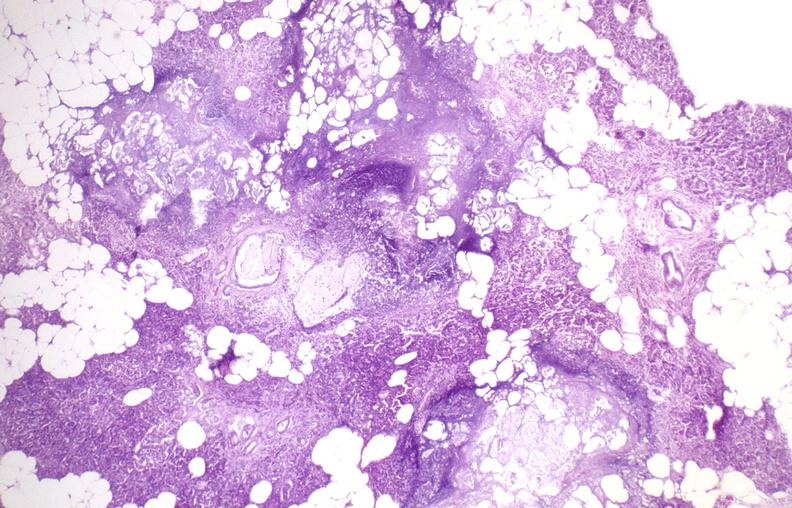where is this?
Answer the question using a single word or phrase. Pancreas 